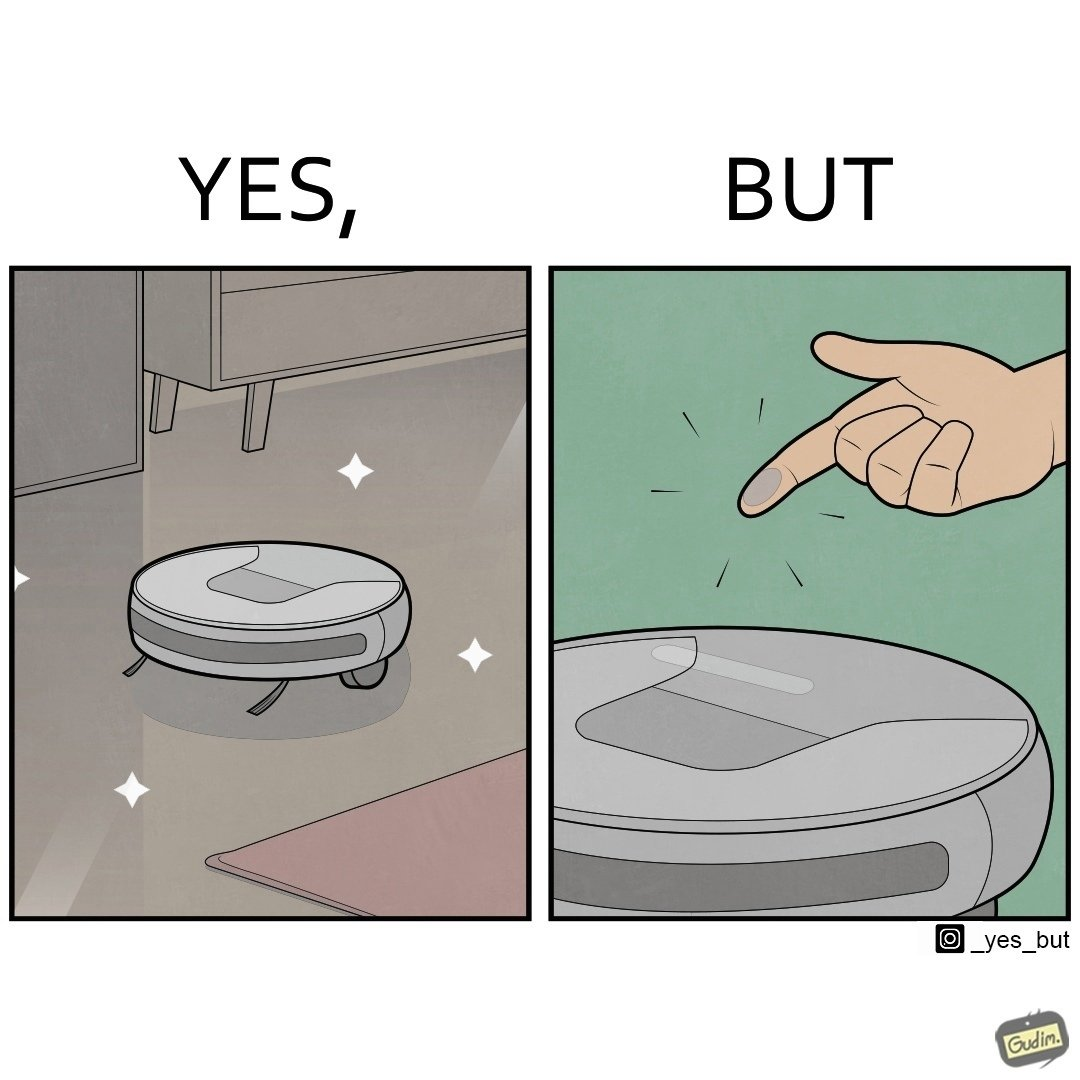Is this a satirical image? Yes, this image is satirical. 